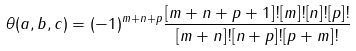Convert formula to latex. <formula><loc_0><loc_0><loc_500><loc_500>\theta ( a , b , c ) = ( - 1 ) ^ { m + n + p } \frac { [ m + n + p + 1 ] ! [ m ] ! [ n ] ! [ p ] ! } { [ m + n ] ! [ n + p ] ! [ p + m ] ! }</formula> 